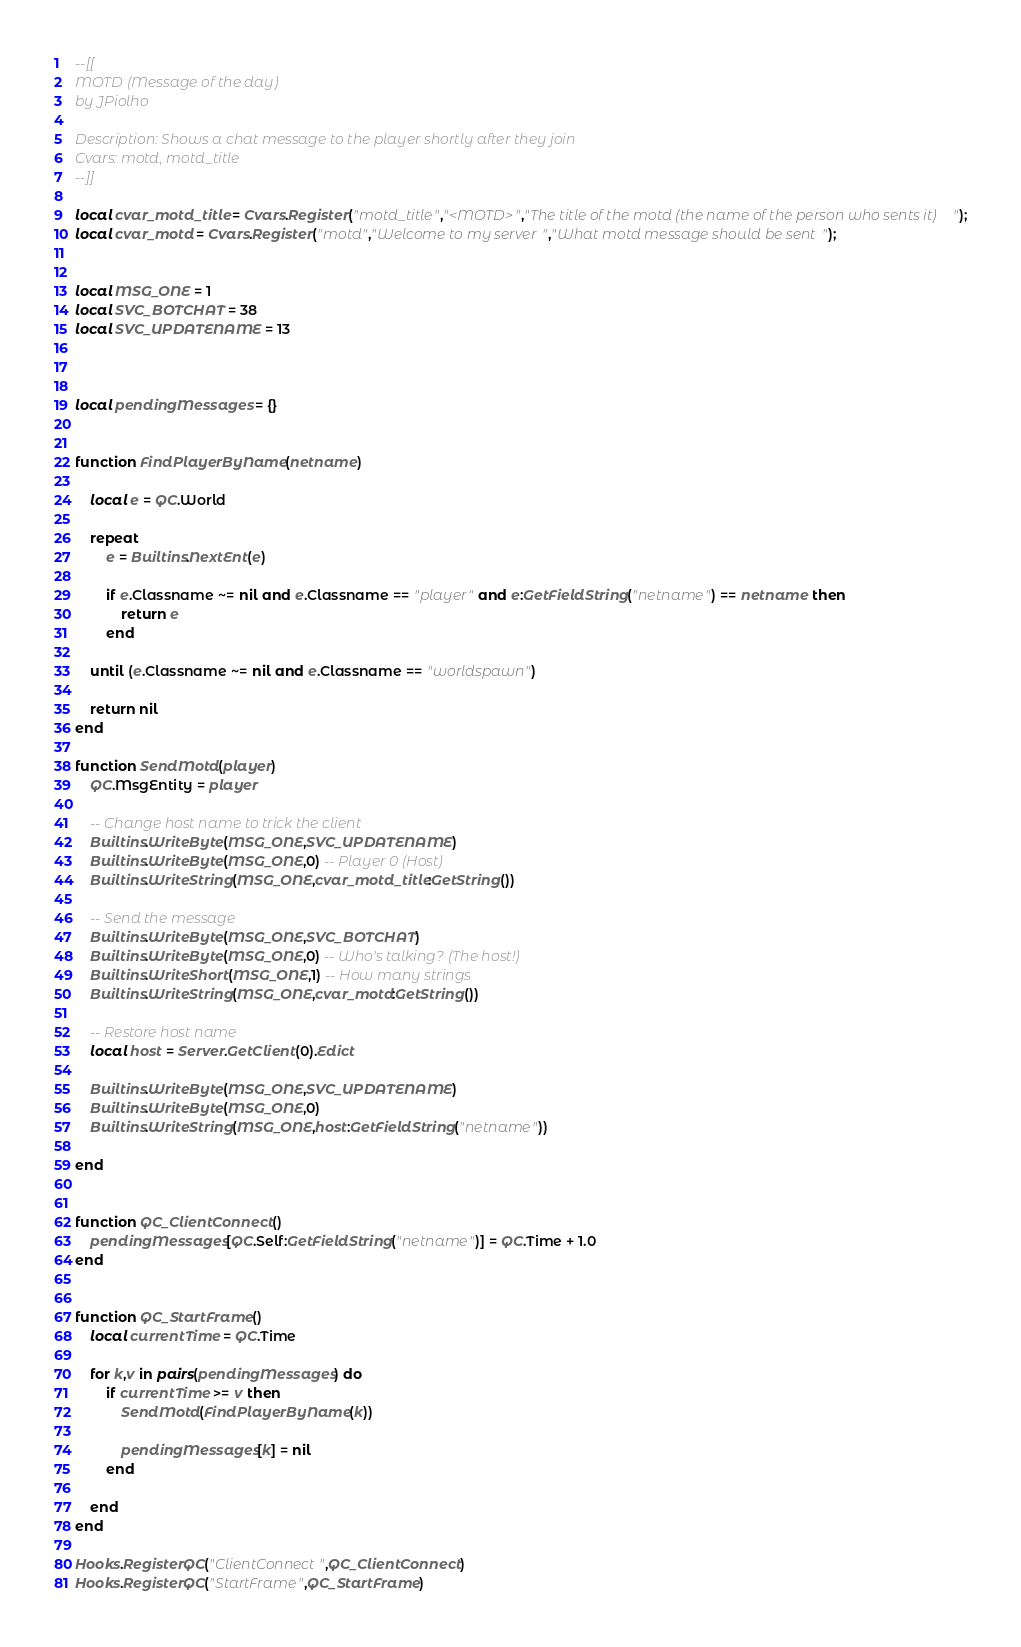<code> <loc_0><loc_0><loc_500><loc_500><_Lua_>--[[
MOTD (Message of the day)
by JPiolho

Description: Shows a chat message to the player shortly after they join
Cvars: motd, motd_title
--]]

local cvar_motd_title = Cvars.Register("motd_title","<MOTD>","The title of the motd (the name of the person who sents it)");
local cvar_motd = Cvars.Register("motd","Welcome to my server","What motd message should be sent");


local MSG_ONE = 1
local SVC_BOTCHAT = 38
local SVC_UPDATENAME = 13



local pendingMessages = {}


function FindPlayerByName(netname)

    local e = QC.World
    
    repeat
        e = Builtins.NextEnt(e)
        
        if e.Classname ~= nil and e.Classname == "player" and e:GetFieldString("netname") == netname then
            return e
        end
        
    until (e.Classname ~= nil and e.Classname == "worldspawn")

    return nil
end

function SendMotd(player)    
    QC.MsgEntity = player
    
    -- Change host name to trick the client
    Builtins.WriteByte(MSG_ONE,SVC_UPDATENAME)
    Builtins.WriteByte(MSG_ONE,0) -- Player 0 (Host)
    Builtins.WriteString(MSG_ONE,cvar_motd_title:GetString())
    
    -- Send the message
    Builtins.WriteByte(MSG_ONE,SVC_BOTCHAT)
    Builtins.WriteByte(MSG_ONE,0) -- Who's talking? (The host!)
    Builtins.WriteShort(MSG_ONE,1) -- How many strings
    Builtins.WriteString(MSG_ONE,cvar_motd:GetString())
    
    -- Restore host name
    local host = Server.GetClient(0).Edict
    
    Builtins.WriteByte(MSG_ONE,SVC_UPDATENAME)
    Builtins.WriteByte(MSG_ONE,0)
    Builtins.WriteString(MSG_ONE,host:GetFieldString("netname"))
    
end


function QC_ClientConnect()
    pendingMessages[QC.Self:GetFieldString("netname")] = QC.Time + 1.0
end


function QC_StartFrame()
    local currentTime = QC.Time
    
    for k,v in pairs(pendingMessages) do
        if currentTime >= v then
            SendMotd(FindPlayerByName(k))
            
            pendingMessages[k] = nil
        end
        
    end
end

Hooks.RegisterQC("ClientConnect",QC_ClientConnect)
Hooks.RegisterQC("StartFrame",QC_StartFrame)</code> 